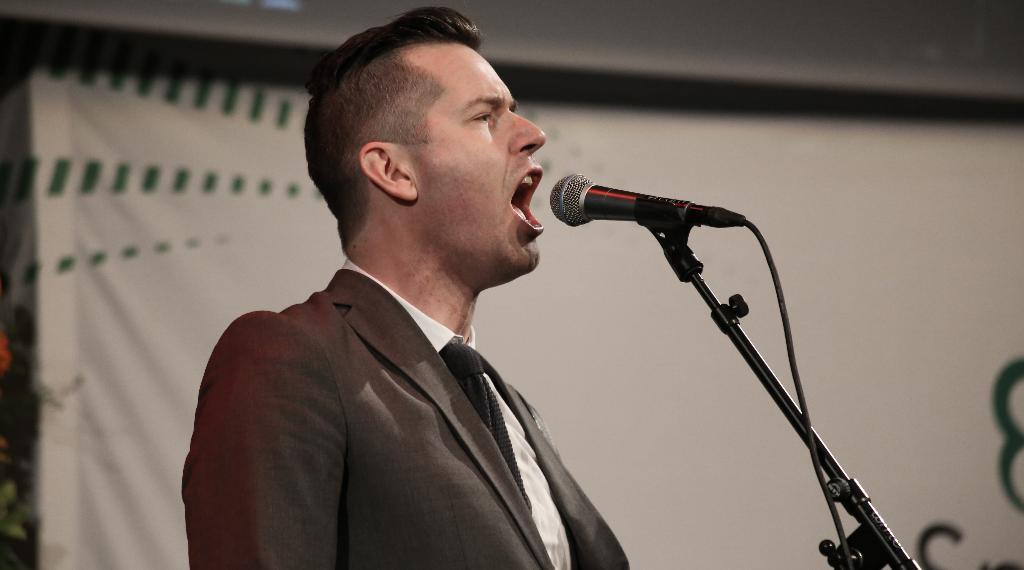Who or what is the main subject in the image? There is a person in the image. What object is the person holding in the image? There is a mic in the image. What is the mic attached to in the image? There is a mic holder in the image. What can be seen in the background of the image? There is a banner in the background of the image. What type of tray is being used by the person in the image? There is no tray present in the image. What is the person learning in the image? The image does not show the person learning anything; it only shows them holding a mic. 